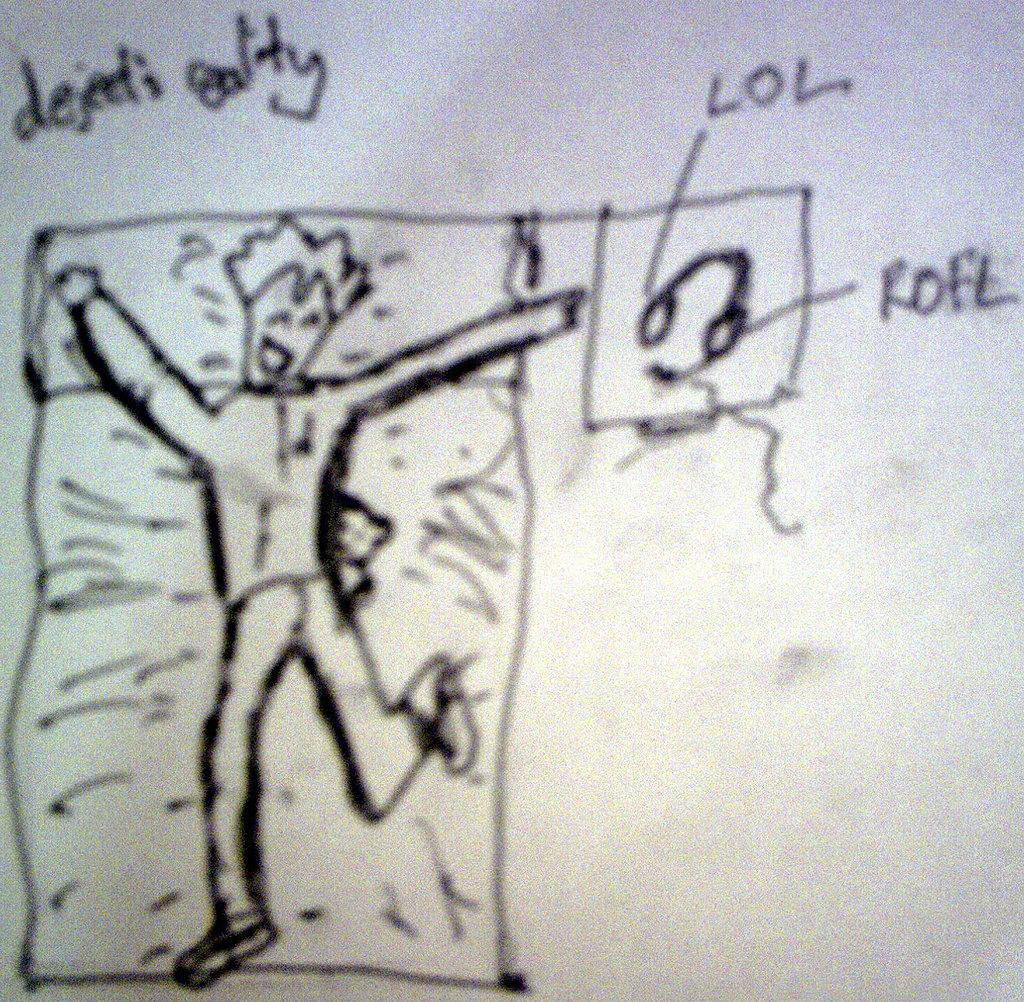What is the medium of the image? The image is a drawing on a paper. What is the subject of the drawing? The drawing depicts a man dancing. What object is beside the man in the drawing? There is a headset beside the man in the drawing. What can be found at the top of the drawing? There is text at the top of the drawing. What is the tendency of the porter in the image? There is no porter present in the image, so it is not possible to determine any tendencies. What point is the man trying to make in the drawing? The drawing does not convey a specific point or message; it simply depicts a man dancing. 